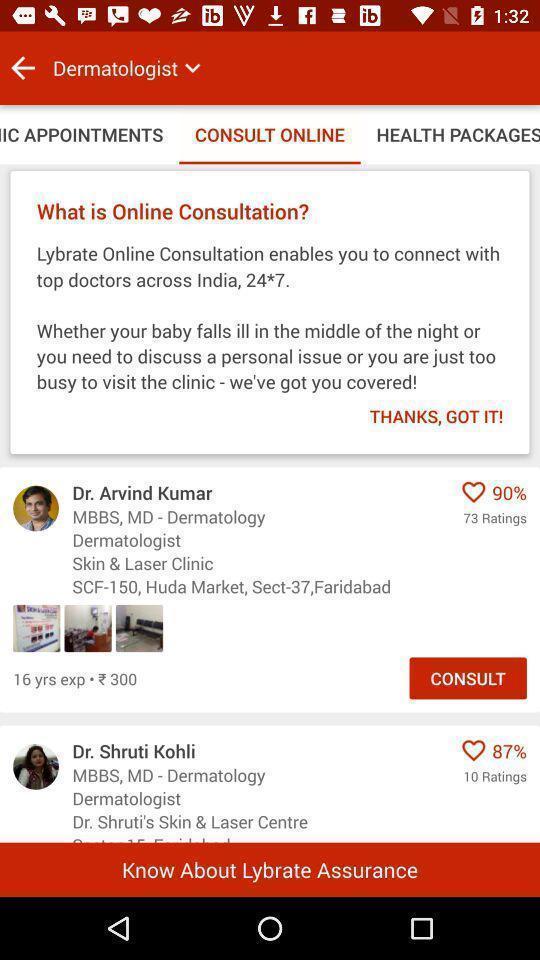Summarize the information in this screenshot. Screen shows consult online page in medical application. 